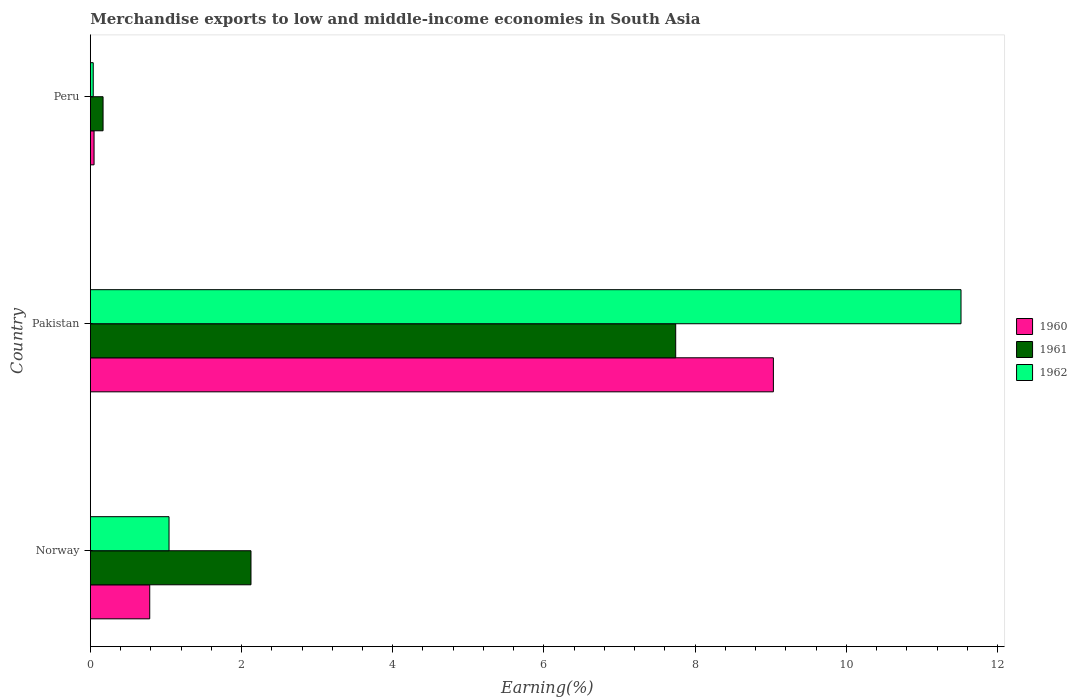How many different coloured bars are there?
Offer a very short reply. 3. Are the number of bars per tick equal to the number of legend labels?
Your response must be concise. Yes. How many bars are there on the 3rd tick from the top?
Keep it short and to the point. 3. In how many cases, is the number of bars for a given country not equal to the number of legend labels?
Offer a very short reply. 0. What is the percentage of amount earned from merchandise exports in 1962 in Norway?
Ensure brevity in your answer.  1.04. Across all countries, what is the maximum percentage of amount earned from merchandise exports in 1962?
Your answer should be very brief. 11.52. Across all countries, what is the minimum percentage of amount earned from merchandise exports in 1960?
Offer a terse response. 0.05. In which country was the percentage of amount earned from merchandise exports in 1961 maximum?
Ensure brevity in your answer.  Pakistan. What is the total percentage of amount earned from merchandise exports in 1961 in the graph?
Offer a terse response. 10.04. What is the difference between the percentage of amount earned from merchandise exports in 1962 in Norway and that in Peru?
Offer a terse response. 1. What is the difference between the percentage of amount earned from merchandise exports in 1960 in Pakistan and the percentage of amount earned from merchandise exports in 1962 in Norway?
Keep it short and to the point. 7.99. What is the average percentage of amount earned from merchandise exports in 1961 per country?
Provide a succinct answer. 3.35. What is the difference between the percentage of amount earned from merchandise exports in 1962 and percentage of amount earned from merchandise exports in 1960 in Peru?
Provide a succinct answer. -0.01. What is the ratio of the percentage of amount earned from merchandise exports in 1961 in Pakistan to that in Peru?
Ensure brevity in your answer.  46.1. Is the percentage of amount earned from merchandise exports in 1961 in Norway less than that in Peru?
Your answer should be very brief. No. What is the difference between the highest and the second highest percentage of amount earned from merchandise exports in 1960?
Offer a terse response. 8.25. What is the difference between the highest and the lowest percentage of amount earned from merchandise exports in 1960?
Offer a very short reply. 8.99. What does the 2nd bar from the top in Pakistan represents?
Offer a very short reply. 1961. Is it the case that in every country, the sum of the percentage of amount earned from merchandise exports in 1962 and percentage of amount earned from merchandise exports in 1961 is greater than the percentage of amount earned from merchandise exports in 1960?
Keep it short and to the point. Yes. How many bars are there?
Offer a very short reply. 9. Are all the bars in the graph horizontal?
Make the answer very short. Yes. What is the difference between two consecutive major ticks on the X-axis?
Your answer should be compact. 2. Does the graph contain any zero values?
Give a very brief answer. No. How many legend labels are there?
Your answer should be very brief. 3. What is the title of the graph?
Offer a terse response. Merchandise exports to low and middle-income economies in South Asia. Does "2012" appear as one of the legend labels in the graph?
Ensure brevity in your answer.  No. What is the label or title of the X-axis?
Offer a very short reply. Earning(%). What is the label or title of the Y-axis?
Give a very brief answer. Country. What is the Earning(%) of 1960 in Norway?
Your answer should be compact. 0.79. What is the Earning(%) in 1961 in Norway?
Your answer should be compact. 2.12. What is the Earning(%) in 1962 in Norway?
Your answer should be very brief. 1.04. What is the Earning(%) of 1960 in Pakistan?
Provide a short and direct response. 9.04. What is the Earning(%) in 1961 in Pakistan?
Make the answer very short. 7.74. What is the Earning(%) in 1962 in Pakistan?
Your answer should be very brief. 11.52. What is the Earning(%) in 1960 in Peru?
Provide a succinct answer. 0.05. What is the Earning(%) of 1961 in Peru?
Offer a terse response. 0.17. What is the Earning(%) of 1962 in Peru?
Make the answer very short. 0.04. Across all countries, what is the maximum Earning(%) in 1960?
Give a very brief answer. 9.04. Across all countries, what is the maximum Earning(%) in 1961?
Ensure brevity in your answer.  7.74. Across all countries, what is the maximum Earning(%) of 1962?
Keep it short and to the point. 11.52. Across all countries, what is the minimum Earning(%) in 1960?
Ensure brevity in your answer.  0.05. Across all countries, what is the minimum Earning(%) in 1961?
Provide a succinct answer. 0.17. Across all countries, what is the minimum Earning(%) in 1962?
Keep it short and to the point. 0.04. What is the total Earning(%) of 1960 in the graph?
Your answer should be compact. 9.87. What is the total Earning(%) in 1961 in the graph?
Keep it short and to the point. 10.04. What is the total Earning(%) of 1962 in the graph?
Your response must be concise. 12.6. What is the difference between the Earning(%) of 1960 in Norway and that in Pakistan?
Give a very brief answer. -8.25. What is the difference between the Earning(%) of 1961 in Norway and that in Pakistan?
Give a very brief answer. -5.62. What is the difference between the Earning(%) of 1962 in Norway and that in Pakistan?
Offer a very short reply. -10.48. What is the difference between the Earning(%) in 1960 in Norway and that in Peru?
Provide a short and direct response. 0.74. What is the difference between the Earning(%) in 1961 in Norway and that in Peru?
Give a very brief answer. 1.96. What is the difference between the Earning(%) in 1962 in Norway and that in Peru?
Your answer should be very brief. 1. What is the difference between the Earning(%) in 1960 in Pakistan and that in Peru?
Make the answer very short. 8.99. What is the difference between the Earning(%) in 1961 in Pakistan and that in Peru?
Keep it short and to the point. 7.58. What is the difference between the Earning(%) in 1962 in Pakistan and that in Peru?
Make the answer very short. 11.48. What is the difference between the Earning(%) in 1960 in Norway and the Earning(%) in 1961 in Pakistan?
Provide a succinct answer. -6.96. What is the difference between the Earning(%) in 1960 in Norway and the Earning(%) in 1962 in Pakistan?
Ensure brevity in your answer.  -10.73. What is the difference between the Earning(%) of 1961 in Norway and the Earning(%) of 1962 in Pakistan?
Provide a short and direct response. -9.39. What is the difference between the Earning(%) in 1960 in Norway and the Earning(%) in 1961 in Peru?
Give a very brief answer. 0.62. What is the difference between the Earning(%) in 1960 in Norway and the Earning(%) in 1962 in Peru?
Provide a succinct answer. 0.75. What is the difference between the Earning(%) in 1961 in Norway and the Earning(%) in 1962 in Peru?
Provide a succinct answer. 2.09. What is the difference between the Earning(%) of 1960 in Pakistan and the Earning(%) of 1961 in Peru?
Provide a short and direct response. 8.87. What is the difference between the Earning(%) of 1960 in Pakistan and the Earning(%) of 1962 in Peru?
Provide a succinct answer. 9. What is the difference between the Earning(%) in 1961 in Pakistan and the Earning(%) in 1962 in Peru?
Provide a short and direct response. 7.71. What is the average Earning(%) of 1960 per country?
Ensure brevity in your answer.  3.29. What is the average Earning(%) in 1961 per country?
Make the answer very short. 3.35. What is the average Earning(%) in 1962 per country?
Offer a terse response. 4.2. What is the difference between the Earning(%) in 1960 and Earning(%) in 1961 in Norway?
Make the answer very short. -1.34. What is the difference between the Earning(%) of 1960 and Earning(%) of 1962 in Norway?
Your response must be concise. -0.26. What is the difference between the Earning(%) in 1961 and Earning(%) in 1962 in Norway?
Your answer should be very brief. 1.08. What is the difference between the Earning(%) of 1960 and Earning(%) of 1961 in Pakistan?
Your response must be concise. 1.29. What is the difference between the Earning(%) in 1960 and Earning(%) in 1962 in Pakistan?
Ensure brevity in your answer.  -2.48. What is the difference between the Earning(%) of 1961 and Earning(%) of 1962 in Pakistan?
Provide a succinct answer. -3.77. What is the difference between the Earning(%) in 1960 and Earning(%) in 1961 in Peru?
Your answer should be very brief. -0.12. What is the difference between the Earning(%) of 1960 and Earning(%) of 1962 in Peru?
Ensure brevity in your answer.  0.01. What is the difference between the Earning(%) in 1961 and Earning(%) in 1962 in Peru?
Offer a terse response. 0.13. What is the ratio of the Earning(%) of 1960 in Norway to that in Pakistan?
Make the answer very short. 0.09. What is the ratio of the Earning(%) of 1961 in Norway to that in Pakistan?
Offer a terse response. 0.27. What is the ratio of the Earning(%) of 1962 in Norway to that in Pakistan?
Ensure brevity in your answer.  0.09. What is the ratio of the Earning(%) of 1960 in Norway to that in Peru?
Your response must be concise. 16.05. What is the ratio of the Earning(%) of 1961 in Norway to that in Peru?
Make the answer very short. 12.65. What is the ratio of the Earning(%) of 1962 in Norway to that in Peru?
Offer a very short reply. 27.36. What is the ratio of the Earning(%) in 1960 in Pakistan to that in Peru?
Offer a terse response. 184.68. What is the ratio of the Earning(%) of 1961 in Pakistan to that in Peru?
Keep it short and to the point. 46.1. What is the ratio of the Earning(%) of 1962 in Pakistan to that in Peru?
Your answer should be compact. 302.79. What is the difference between the highest and the second highest Earning(%) in 1960?
Provide a succinct answer. 8.25. What is the difference between the highest and the second highest Earning(%) of 1961?
Your answer should be very brief. 5.62. What is the difference between the highest and the second highest Earning(%) in 1962?
Your answer should be compact. 10.48. What is the difference between the highest and the lowest Earning(%) of 1960?
Make the answer very short. 8.99. What is the difference between the highest and the lowest Earning(%) in 1961?
Provide a succinct answer. 7.58. What is the difference between the highest and the lowest Earning(%) in 1962?
Give a very brief answer. 11.48. 